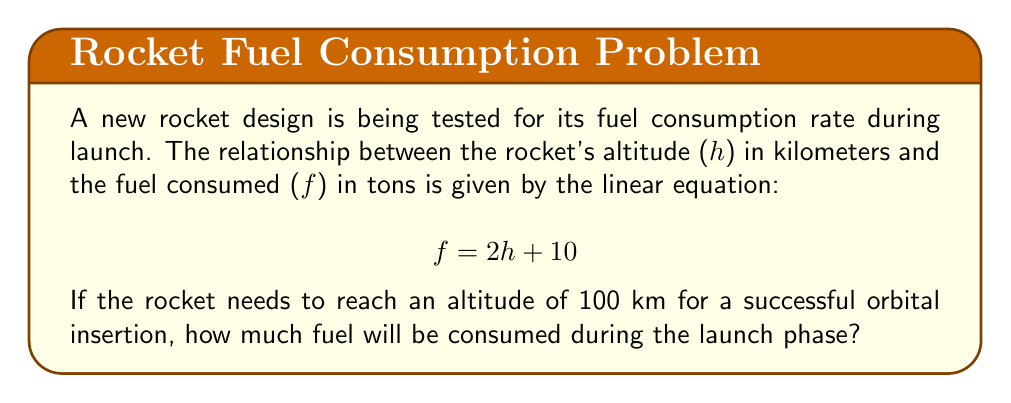Show me your answer to this math problem. To solve this problem, we'll follow these steps:

1) We are given the linear equation relating fuel consumption (f) to altitude (h):
   $$ f = 2h + 10 $$

2) We need to find the fuel consumed when the rocket reaches an altitude of 100 km. So, we'll substitute h = 100 into our equation:
   $$ f = 2(100) + 10 $$

3) Now we can solve this equation:
   $$ f = 200 + 10 $$
   $$ f = 210 $$

4) Therefore, when the rocket reaches an altitude of 100 km, it will have consumed 210 tons of fuel.

This linear relationship allows us to quickly calculate fuel consumption at any altitude, which is crucial for mission planning and ensuring the rocket has sufficient fuel for its intended trajectory.
Answer: 210 tons 